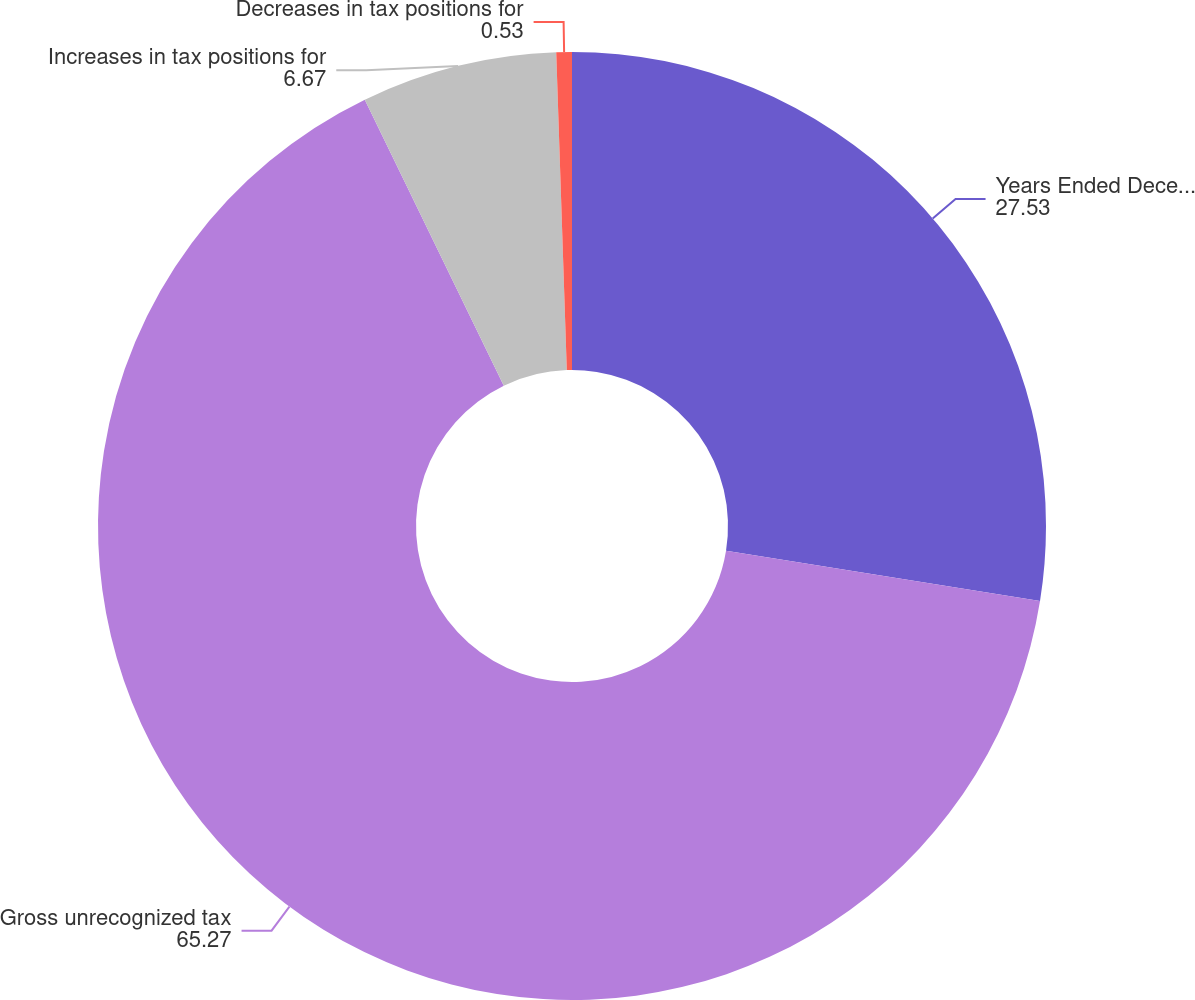Convert chart. <chart><loc_0><loc_0><loc_500><loc_500><pie_chart><fcel>Years Ended December 31 (in<fcel>Gross unrecognized tax<fcel>Increases in tax positions for<fcel>Decreases in tax positions for<nl><fcel>27.53%<fcel>65.27%<fcel>6.67%<fcel>0.53%<nl></chart> 